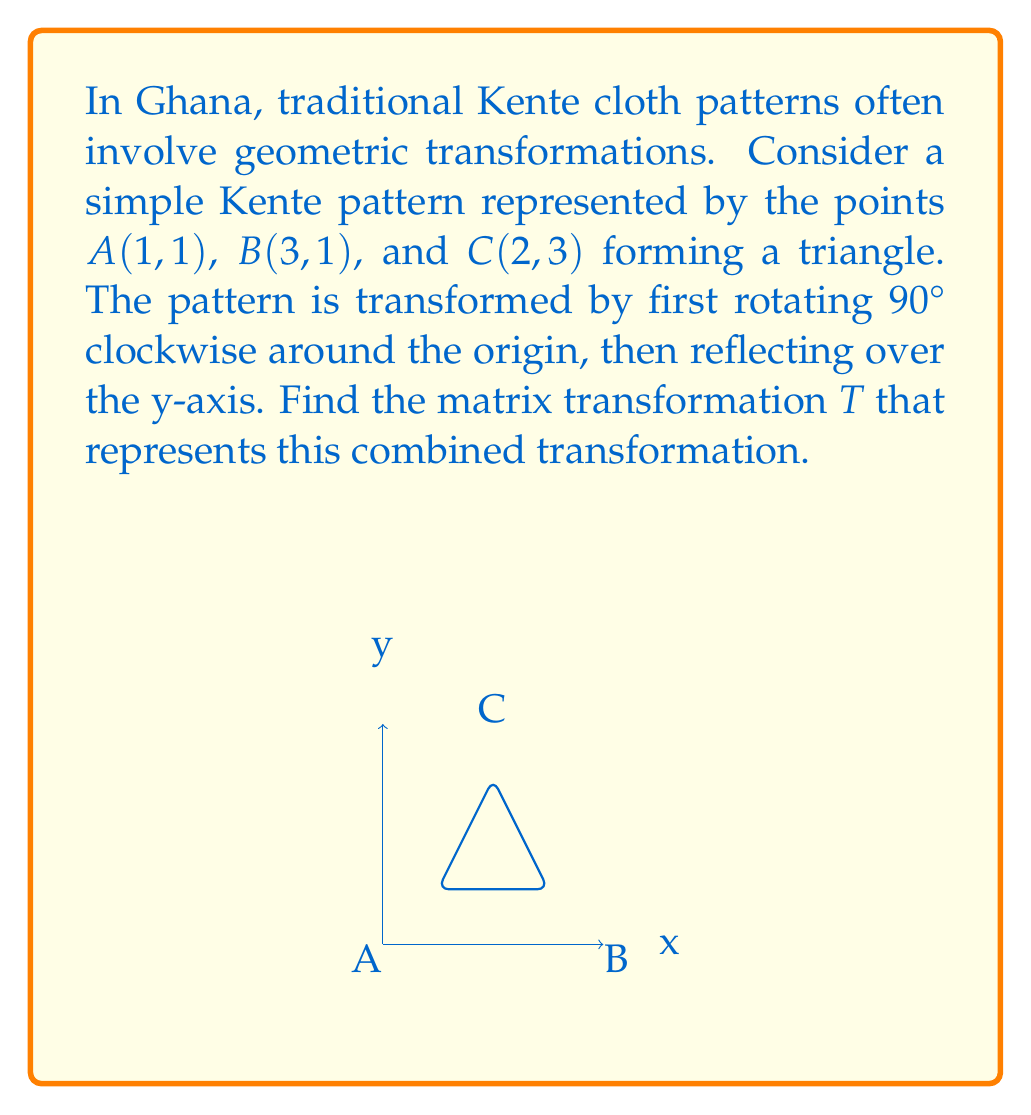Teach me how to tackle this problem. Let's approach this step-by-step:

1) First, we need to recall the matrices for 90° clockwise rotation and reflection over the y-axis:

   90° clockwise rotation: $R = \begin{pmatrix} 0 & 1 \\ -1 & 0 \end{pmatrix}$
   Reflection over y-axis: $F = \begin{pmatrix} -1 & 0 \\ 0 & 1 \end{pmatrix}$

2) The transformation $T$ is the composition of these two transformations, first rotation then reflection. In matrix multiplication, we apply the rightmost matrix first, so:

   $T = F \cdot R$

3) Let's multiply these matrices:

   $T = \begin{pmatrix} -1 & 0 \\ 0 & 1 \end{pmatrix} \cdot \begin{pmatrix} 0 & 1 \\ -1 & 0 \end{pmatrix}$

4) Performing the matrix multiplication:

   $T = \begin{pmatrix} (-1 \cdot 0 + 0 \cdot -1) & (-1 \cdot 1 + 0 \cdot 0) \\ (0 \cdot 0 + 1 \cdot -1) & (0 \cdot 1 + 1 \cdot 0) \end{pmatrix}$

5) Simplifying:

   $T = \begin{pmatrix} 0 & -1 \\ -1 & 0 \end{pmatrix}$

This matrix $T$ represents the combined transformation of rotating 90° clockwise and then reflecting over the y-axis.
Answer: $T = \begin{pmatrix} 0 & -1 \\ -1 & 0 \end{pmatrix}$ 